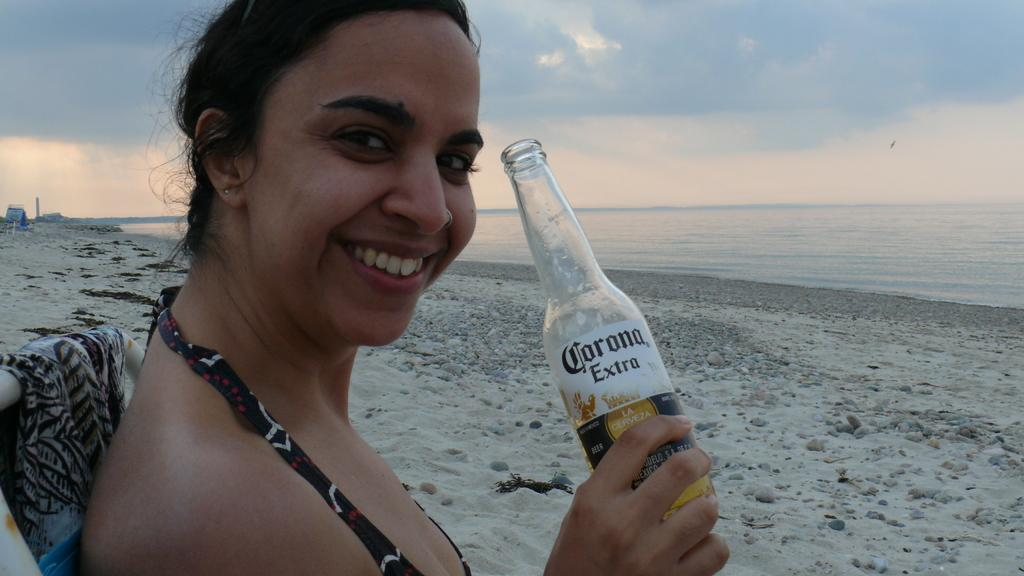Who is present in the image? There is a woman in the picture. What is the woman holding in her hand? The woman is holding a bottle in her hand. What is the woman's facial expression? The woman is smiling. What is the woman sitting on? The woman is sitting on a chair. What type of environment is depicted in the image? There is sand and water visible in the image, suggesting a beach setting. What is the weather like in the image? The sky is cloudy in the image. What type of rail can be seen in the image? There is no rail present in the image. Is the woman playing volleyball in the image? No, the woman is not playing volleyball in the image; she is sitting on a chair and holding a bottle. What type of sofa is visible in the image? There is no sofa present in the image. 